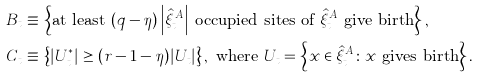<formula> <loc_0><loc_0><loc_500><loc_500>B _ { t } \equiv & \, \left \{ \text {at least $(q-\eta)\left|\hat{\xi}_{t}^{A}\right|$ occupied sites of $\hat{\xi}_{t}^{A}$ give birth} \right \} , \\ C _ { t } \equiv & \, \left \{ | U ^ { * } _ { t } | \geq ( r - 1 - \eta ) | U _ { t } | \right \} , \text { where } U _ { t } = \left \{ x \in \hat { \xi } _ { t } ^ { A } \colon x \text { gives birth} \right \} .</formula> 